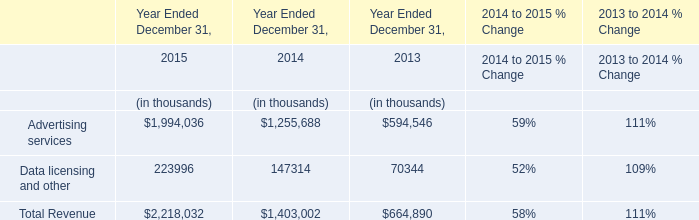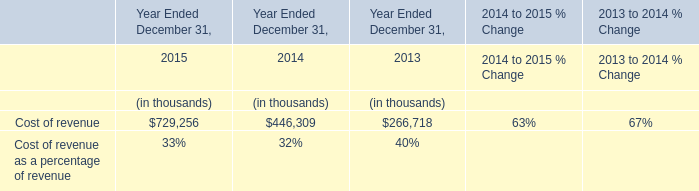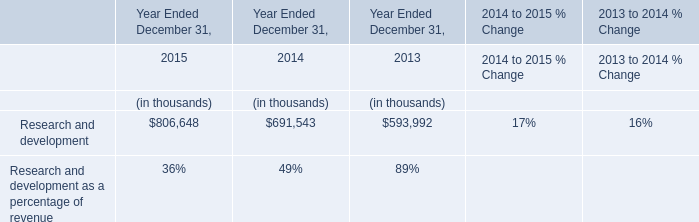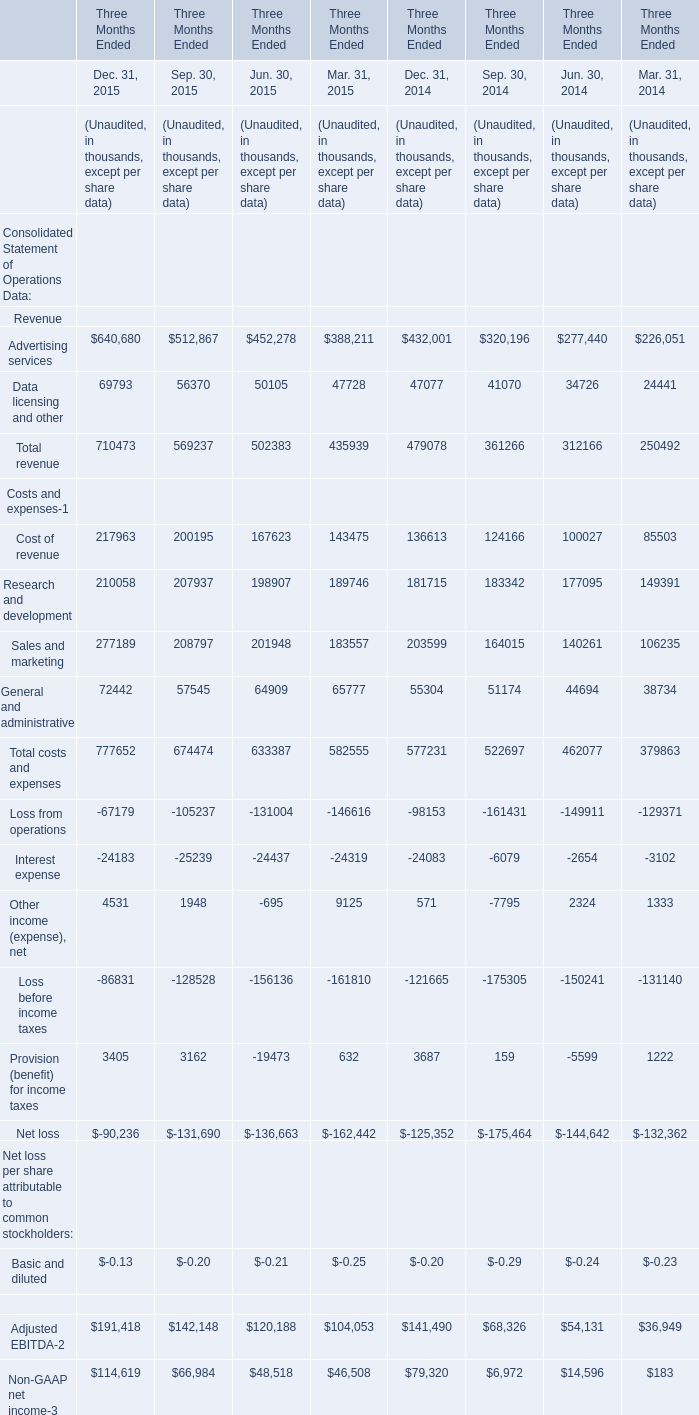What's the total amount of the Advertising services for Revenue in the years where Data licensing and other is greater than 100000? (in thousand) 
Computations: (((((((640680 + 512867) + 452278) + 388211) + 432001) + 320196) + 277440) + 226051)
Answer: 3249724.0. 